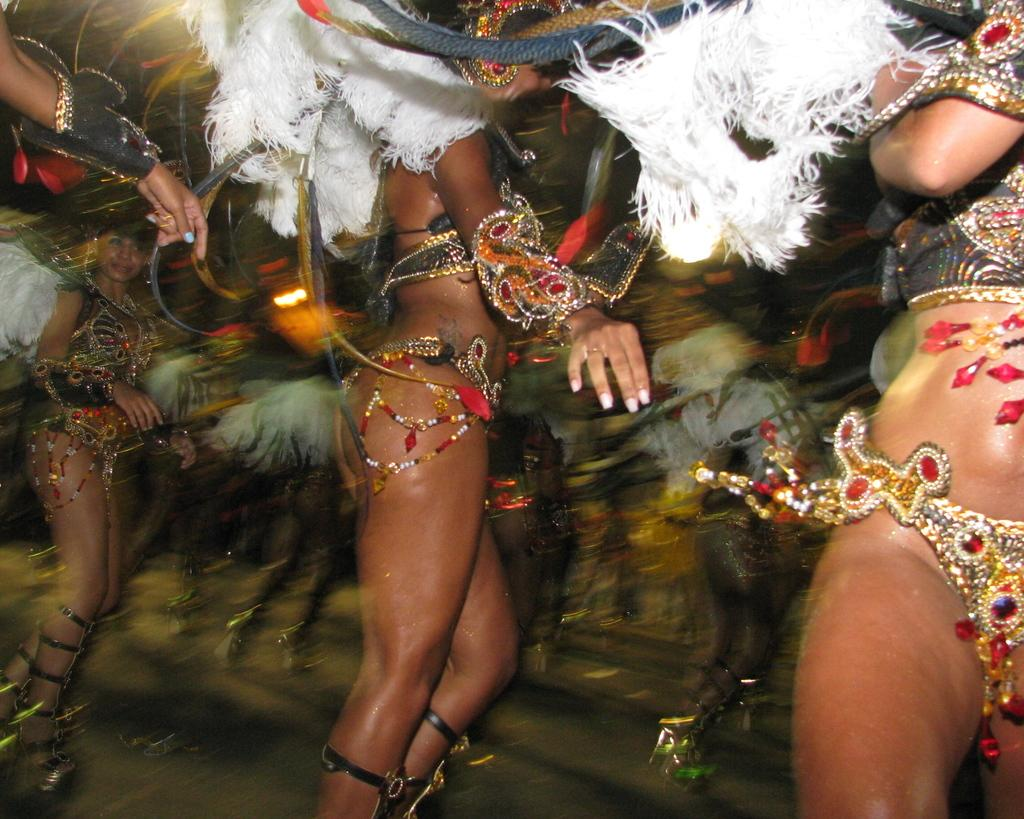Who or what can be seen in the image? There are people in the image. What are the people wearing? The people are wearing costumes. What are the people doing in the image? The people are dancing. What type of bait is being used by the people in the image? There is no bait present in the image; the people are wearing costumes and dancing. What kind of pancake can be seen on the table in the image? There is no table or pancake present in the image; the people are wearing costumes and dancing. 